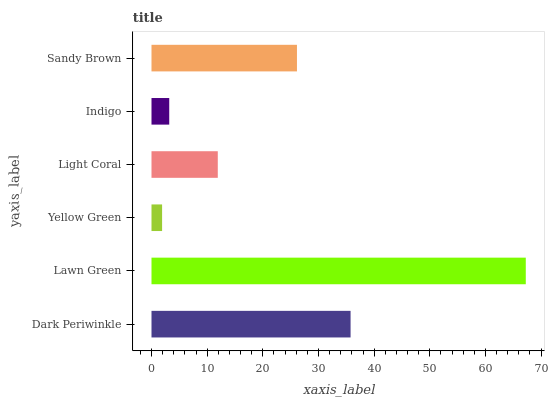Is Yellow Green the minimum?
Answer yes or no. Yes. Is Lawn Green the maximum?
Answer yes or no. Yes. Is Lawn Green the minimum?
Answer yes or no. No. Is Yellow Green the maximum?
Answer yes or no. No. Is Lawn Green greater than Yellow Green?
Answer yes or no. Yes. Is Yellow Green less than Lawn Green?
Answer yes or no. Yes. Is Yellow Green greater than Lawn Green?
Answer yes or no. No. Is Lawn Green less than Yellow Green?
Answer yes or no. No. Is Sandy Brown the high median?
Answer yes or no. Yes. Is Light Coral the low median?
Answer yes or no. Yes. Is Lawn Green the high median?
Answer yes or no. No. Is Dark Periwinkle the low median?
Answer yes or no. No. 